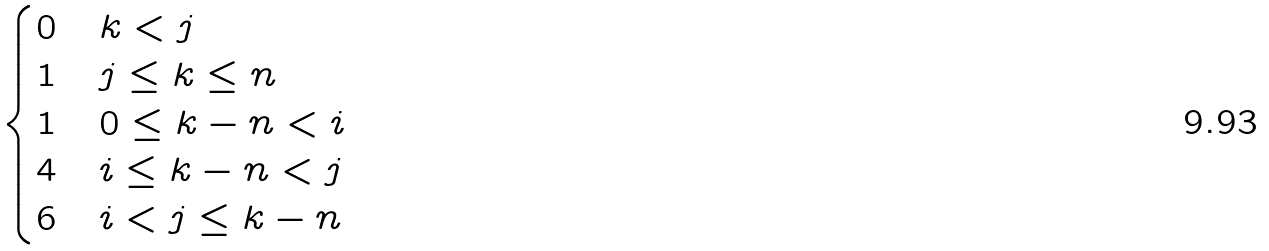<formula> <loc_0><loc_0><loc_500><loc_500>\begin{cases} 0 & k < j \\ 1 & j \leq k \leq n \\ 1 & 0 \leq k - n < i \\ 4 & i \leq k - n < j \\ 6 & i < j \leq k - n \end{cases}</formula> 